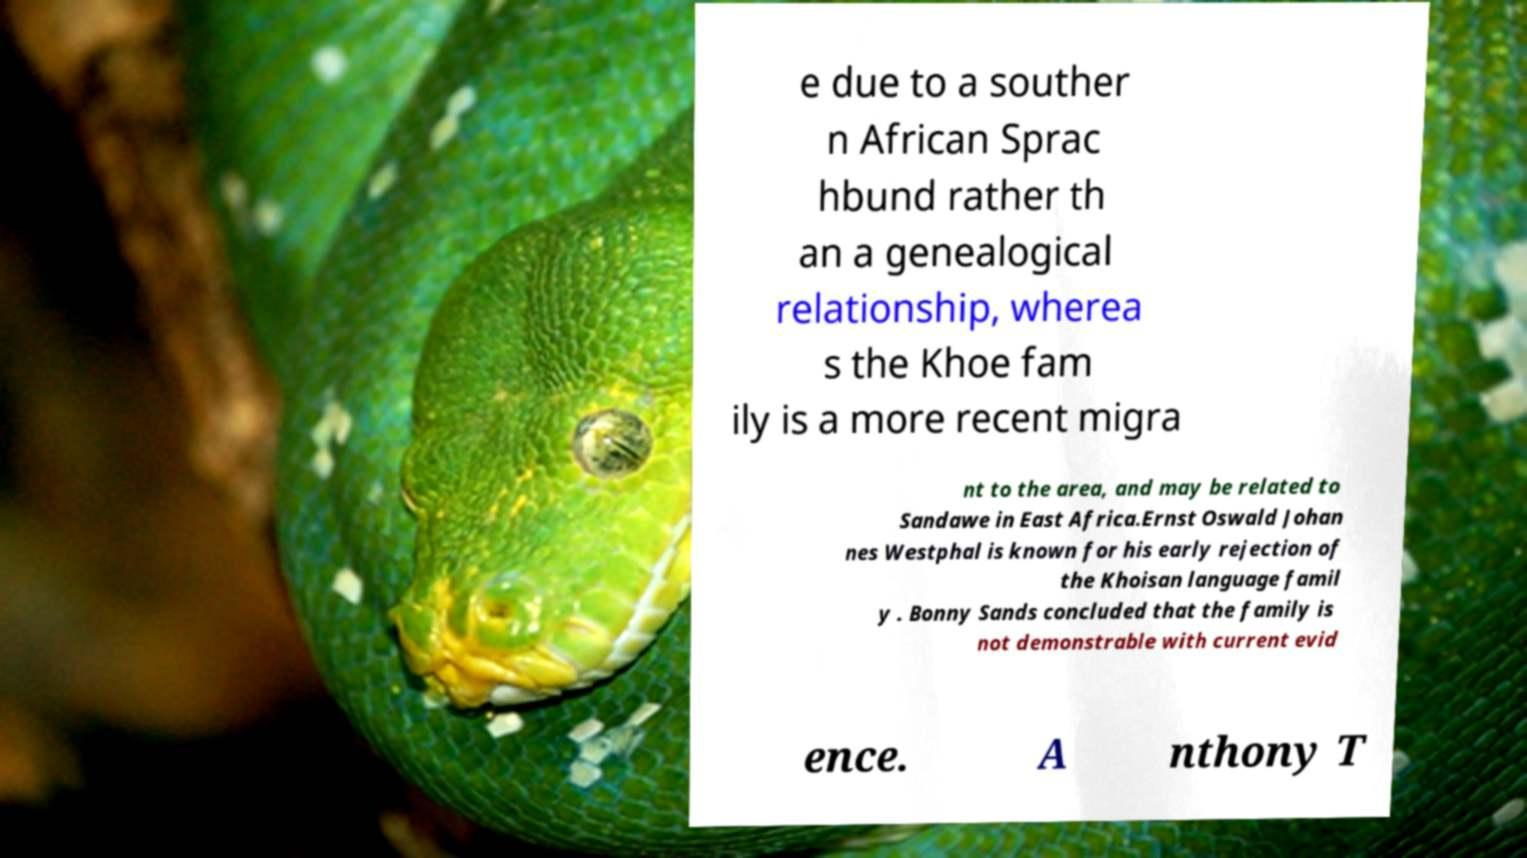Please read and relay the text visible in this image. What does it say? e due to a souther n African Sprac hbund rather th an a genealogical relationship, wherea s the Khoe fam ily is a more recent migra nt to the area, and may be related to Sandawe in East Africa.Ernst Oswald Johan nes Westphal is known for his early rejection of the Khoisan language famil y . Bonny Sands concluded that the family is not demonstrable with current evid ence. A nthony T 